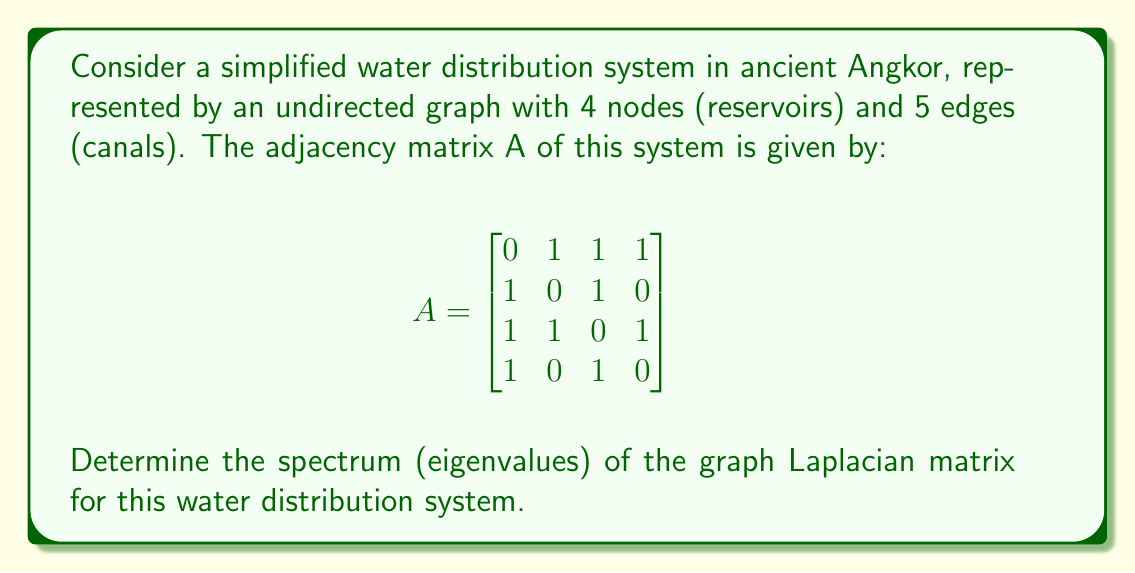Help me with this question. To solve this problem, we'll follow these steps:

1) First, we need to calculate the degree matrix D. The degree of each node is the sum of its connections:
   Node 1: 3, Node 2: 2, Node 3: 3, Node 4: 2
   
   $$D = \begin{bmatrix}
   3 & 0 & 0 & 0 \\
   0 & 2 & 0 & 0 \\
   0 & 0 & 3 & 0 \\
   0 & 0 & 0 & 2
   \end{bmatrix}$$

2) The graph Laplacian L is defined as L = D - A:

   $$L = D - A = \begin{bmatrix}
   3 & -1 & -1 & -1 \\
   -1 & 2 & -1 & 0 \\
   -1 & -1 & 3 & -1 \\
   -1 & 0 & -1 & 2
   \end{bmatrix}$$

3) To find the eigenvalues, we need to solve the characteristic equation:
   $det(L - \lambda I) = 0$

4) Expanding this determinant:
   $\lambda^4 - 10\lambda^3 + 31\lambda^2 - 30\lambda = 0$

5) Factoring this equation:
   $\lambda(\lambda^3 - 10\lambda^2 + 31\lambda - 30) = 0$
   $\lambda(\lambda - 1)(\lambda - 4)(\lambda - 5) = 0$

6) Solving for λ, we get the eigenvalues:
   $\lambda_1 = 0$, $\lambda_2 = 1$, $\lambda_3 = 4$, $\lambda_4 = 5$

These eigenvalues form the spectrum of the graph Laplacian.
Answer: $\{0, 1, 4, 5\}$ 